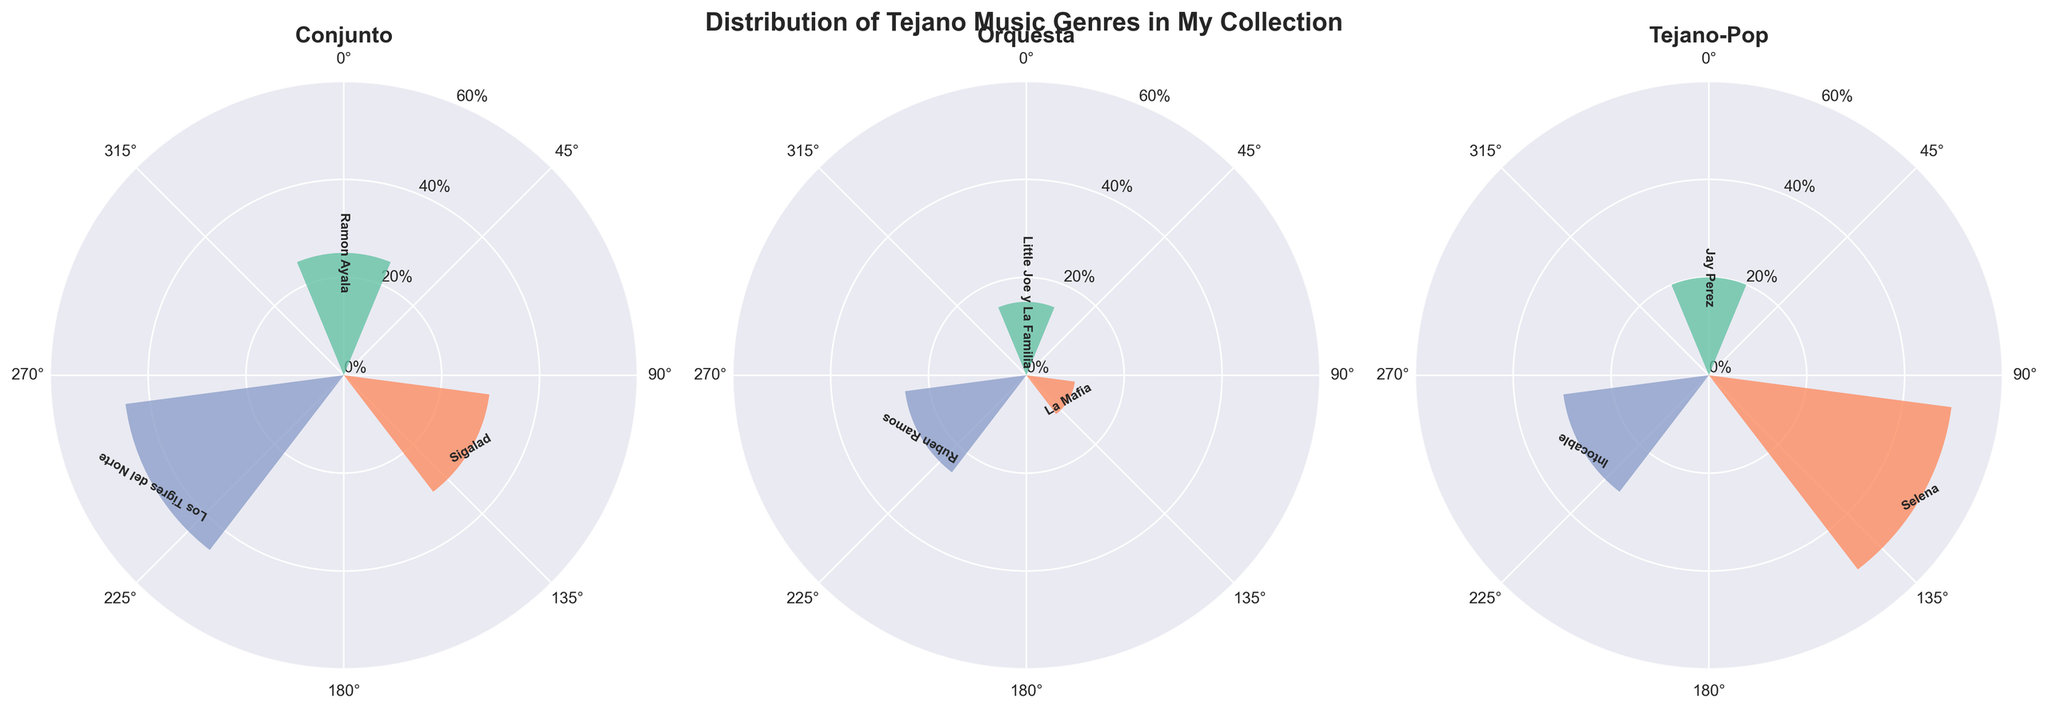What is the title of the entire figure? The title is prominently positioned at the top center of the figure. It reads "Distribution of Tejano Music Genres in My Collection".
Answer: Distribution of Tejano Music Genres in My Collection How many genres are displayed in the figure? There are three distinct subplots shown in the figure, each representing a different genre: Conjunto, Orquesta, and Tejano-Pop.
Answer: 3 Which artist has the highest percentage in the Conjunto genre? In the Conjunto subplot, the bars depict the radii (percentages). The artist with the tallest bar is Los Tigres del Norte at 45%.
Answer: Los Tigres del Norte What is the total percentage of Tejano-Pop genre in the collection? By summing the percentages of all artists in the Tejano-Pop genre (Jay Perez: 20%, Selena: 50%, Intocable: 30%), we get 20% + 50% + 30% = 100%.
Answer: 100% Which artist has the lowest percentage in the Orquesta genre? In the Orquesta subplot, the smallest bar belongs to La Mafia with a percentage of 10%.
Answer: La Mafia Compare the radii of Jay Perez and Selena in the Tejano-Pop genre. Who has the larger percentage? In the Tejano-Pop subplot, Selena has a taller bar (50%) compared to Jay Perez (20%). Hence, Selena has the larger percentage.
Answer: Selena What is the average percentage of artists in the Conjunto genre? In the Conjunto subplot, the percentages are Ramon Ayala: 25%, Sigalad: 30%, and Los Tigres del Norte: 45%. The average is (25% + 30% + 45%) / 3 = 100% / 3 ≈ 33.33%.
Answer: 33.33% Which genre has the most uniform distribution among its artists? A genre with similar bar heights for its artists indicates a uniform distribution. Conjunto shows 25%, 30%, and 45%, Orquesta has 15%, 10%, and 25%, and Tejano-Pop displays 20%, 50%, and 30%. Conjunto and Orquesta are more uniform. Orquesta is relatively more uniform than Conjunto due to smaller variations.
Answer: Orquesta If genre Conjunto's artists' total is combined, does it exceed Tejano-Pop’s total percentage? First, sum the percentages for Conjunto (25% + 30% + 45% = 100%), and Tejano-Pop (20% + 50% + 30% = 100%). Both sums are equal at 100%. So, Conjunto does not exceed Tejano-Pop.
Answer: No Which genre has the highest maximum percentage for any single artist? Comparing the tallest bars across genres, Conjunto's Los Tigres del Norte has 45%, Orquesta's Ruben Ramos has 25%, and Tejano-Pop's Selena has 50%. Selena (Tejano-Pop) has the highest percentage.
Answer: Tejano-Pop 